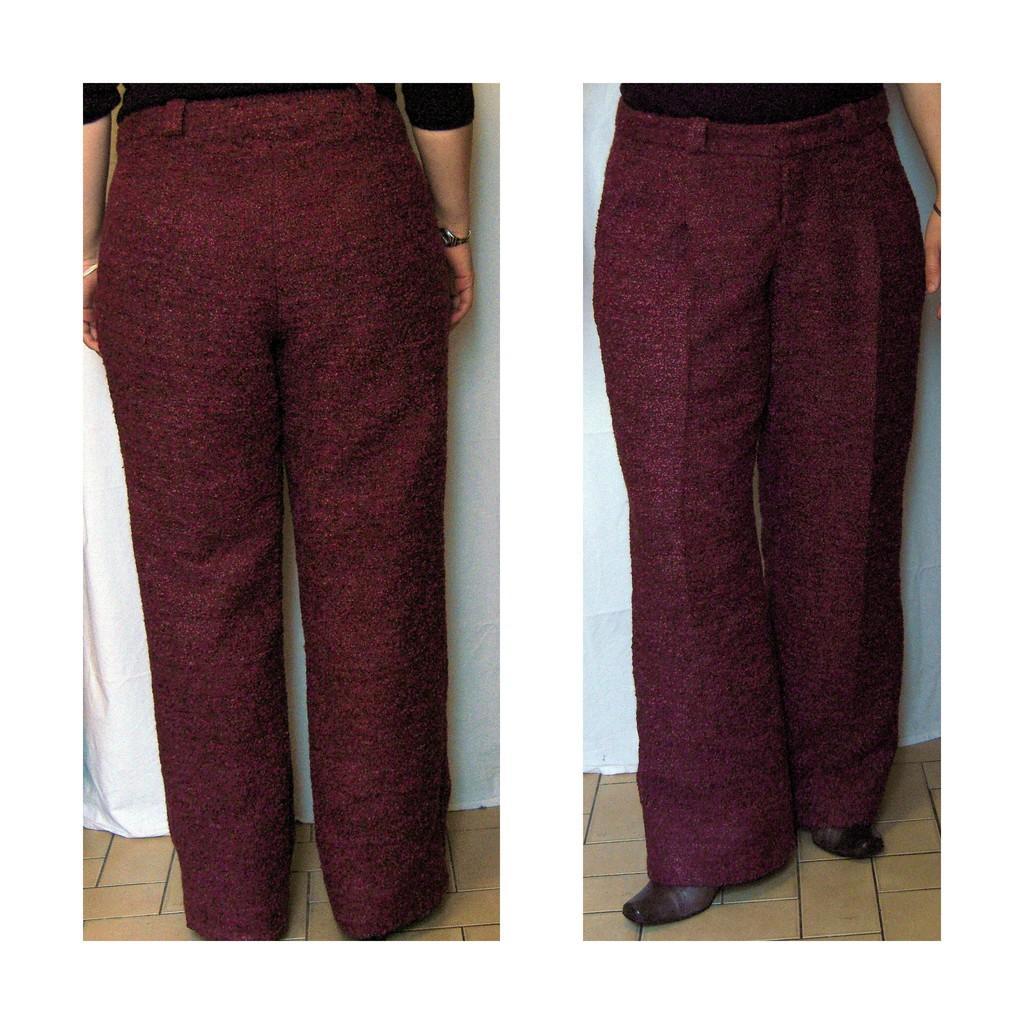Could you give a brief overview of what you see in this image? It is the collage of two images. In two images we can see that there is a red pant. In the background there is a white colour cloth. 